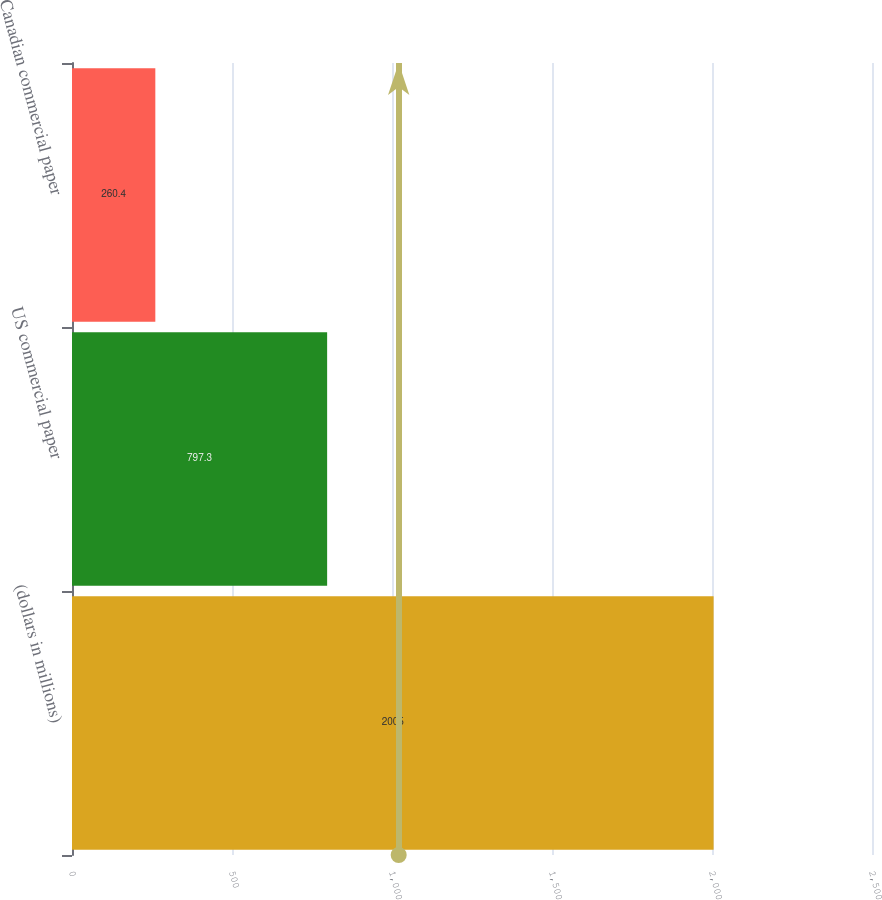Convert chart. <chart><loc_0><loc_0><loc_500><loc_500><bar_chart><fcel>(dollars in millions)<fcel>US commercial paper<fcel>Canadian commercial paper<nl><fcel>2005<fcel>797.3<fcel>260.4<nl></chart> 